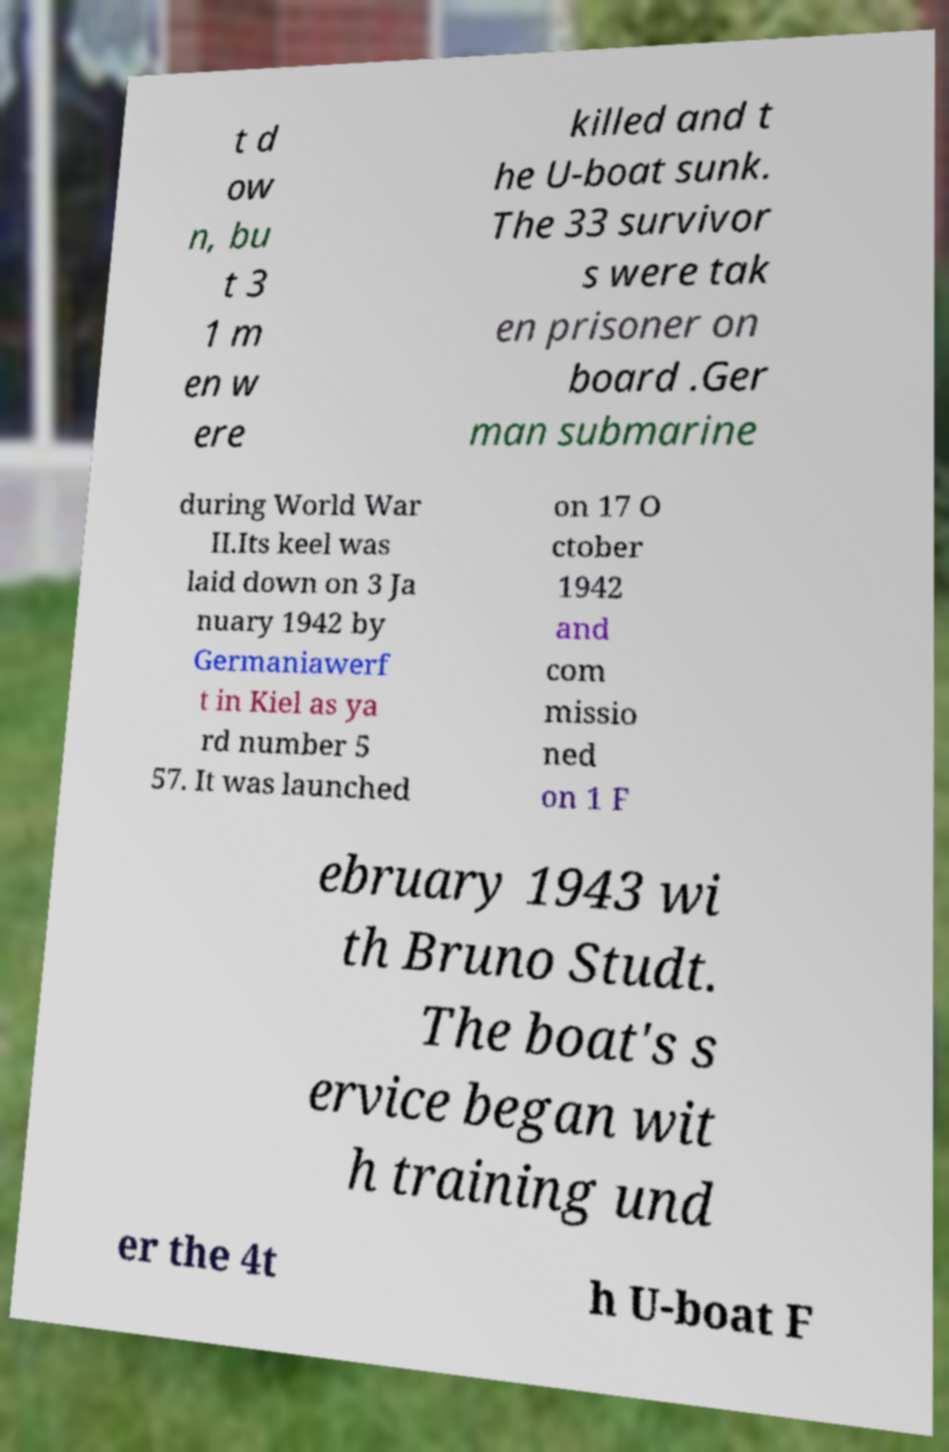Can you accurately transcribe the text from the provided image for me? t d ow n, bu t 3 1 m en w ere killed and t he U-boat sunk. The 33 survivor s were tak en prisoner on board .Ger man submarine during World War II.Its keel was laid down on 3 Ja nuary 1942 by Germaniawerf t in Kiel as ya rd number 5 57. It was launched on 17 O ctober 1942 and com missio ned on 1 F ebruary 1943 wi th Bruno Studt. The boat's s ervice began wit h training und er the 4t h U-boat F 